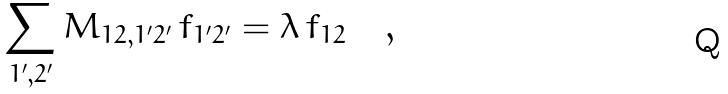<formula> <loc_0><loc_0><loc_500><loc_500>\sum _ { 1 ^ { \prime } , 2 ^ { \prime } } M _ { 1 2 , 1 ^ { \prime } 2 ^ { \prime } } \, f _ { 1 ^ { \prime } 2 ^ { \prime } } = \lambda \, f _ { 1 2 } \quad ,</formula> 